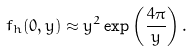<formula> <loc_0><loc_0><loc_500><loc_500>f _ { h } ( 0 , y ) \approx y ^ { 2 } \exp \left ( \frac { 4 \pi } { y } \right ) .</formula> 